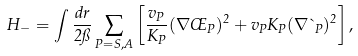Convert formula to latex. <formula><loc_0><loc_0><loc_500><loc_500>H _ { - } = \int \frac { d r } { 2 \pi } \sum _ { P = S , A } \left [ \frac { v _ { P } } { K _ { P } } ( \nabla \phi _ { P } ) ^ { 2 } + v _ { P } K _ { P } ( \nabla \theta _ { P } ) ^ { 2 } \right ] ,</formula> 